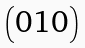<formula> <loc_0><loc_0><loc_500><loc_500>\begin{pmatrix} 0 1 0 \end{pmatrix}</formula> 